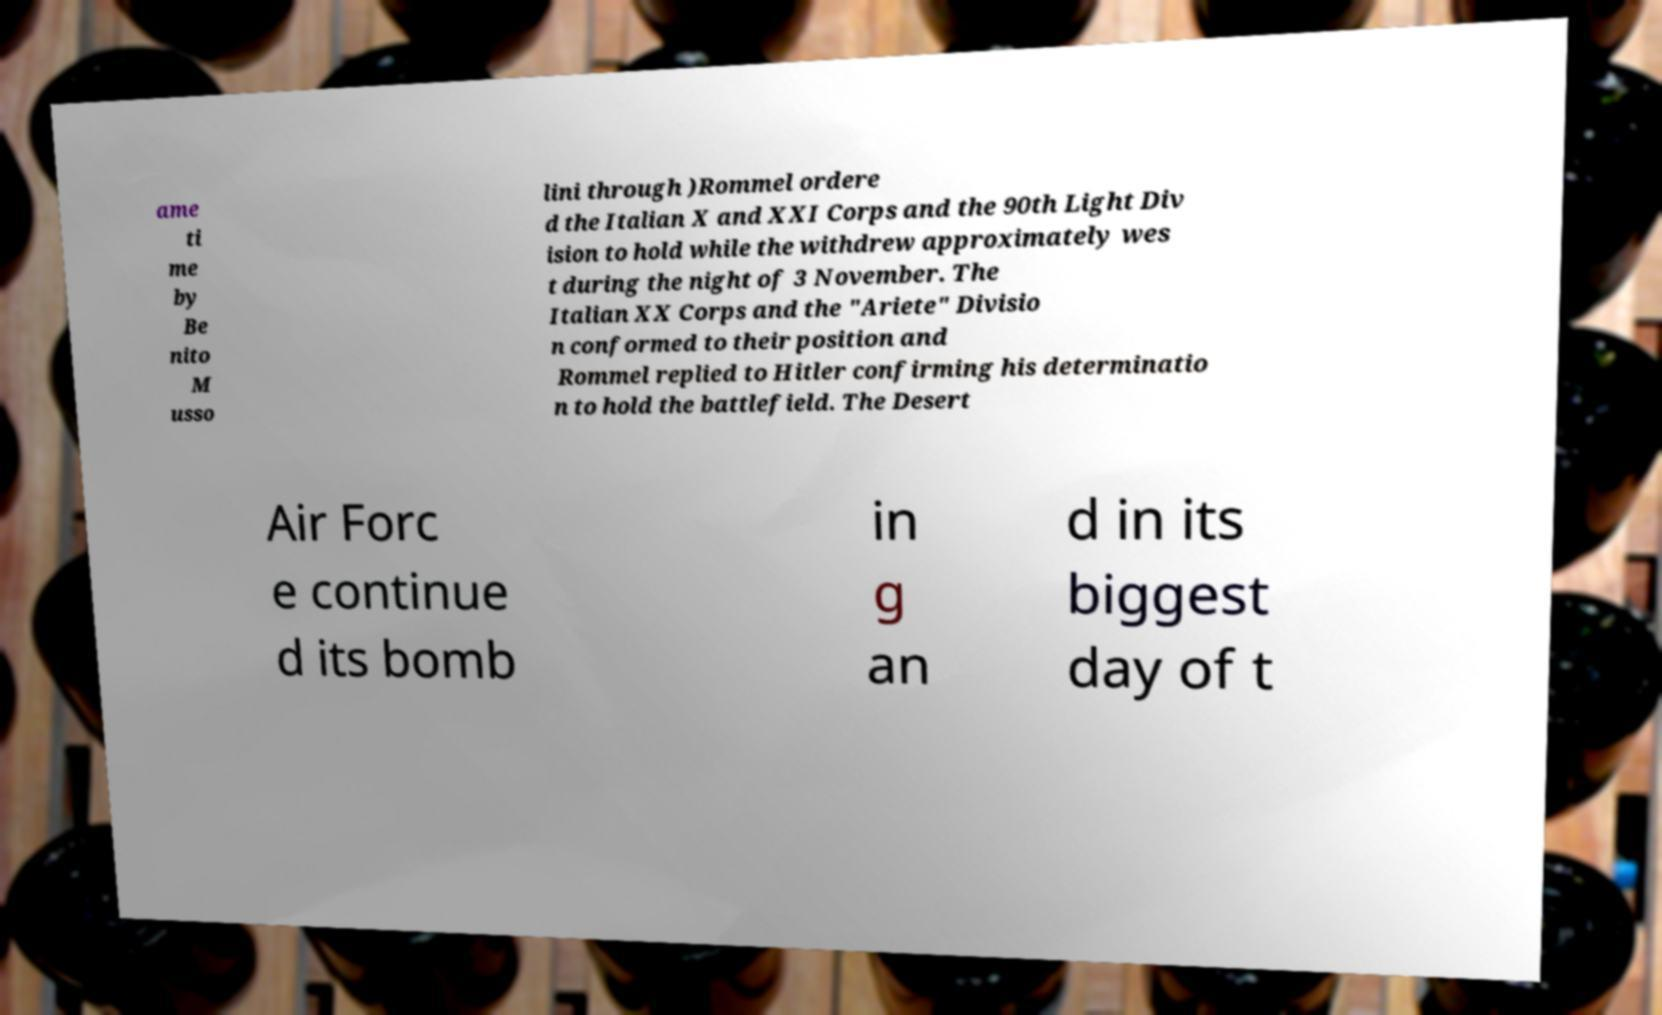Please read and relay the text visible in this image. What does it say? ame ti me by Be nito M usso lini through )Rommel ordere d the Italian X and XXI Corps and the 90th Light Div ision to hold while the withdrew approximately wes t during the night of 3 November. The Italian XX Corps and the "Ariete" Divisio n conformed to their position and Rommel replied to Hitler confirming his determinatio n to hold the battlefield. The Desert Air Forc e continue d its bomb in g an d in its biggest day of t 